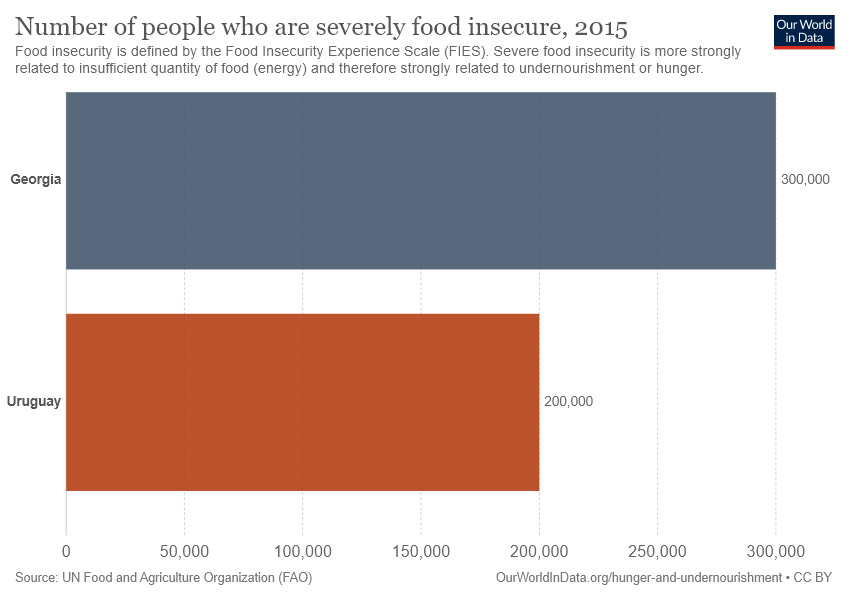Mention a couple of crucial points in this snapshot. The difference in the number of people food insecure is not greater than 150,000. Uruguay has a lower number of people who are food insecure compared to other countries. 